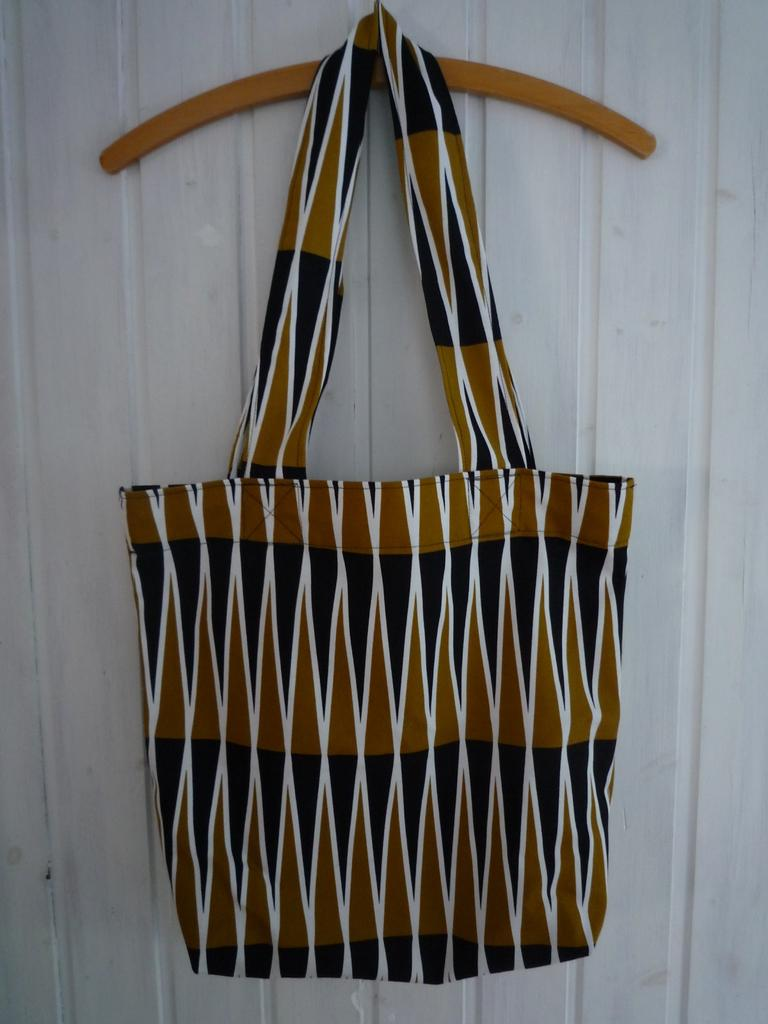What object is present in the image that can be used for carrying items? There is a bag in the image that can be used for carrying items. How is the bag positioned in the image? The bag is hanged on a hanger in the image. What can be seen behind the bag in the image? There is a wall in the background of the image. How many ants are crawling on the bag in the image? There are no ants present in the image; it only shows a bag hanging on a hanger with a wall in the background. 